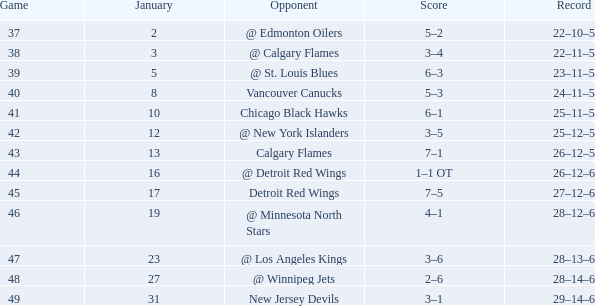What points have a 4-1 score? 62.0. 